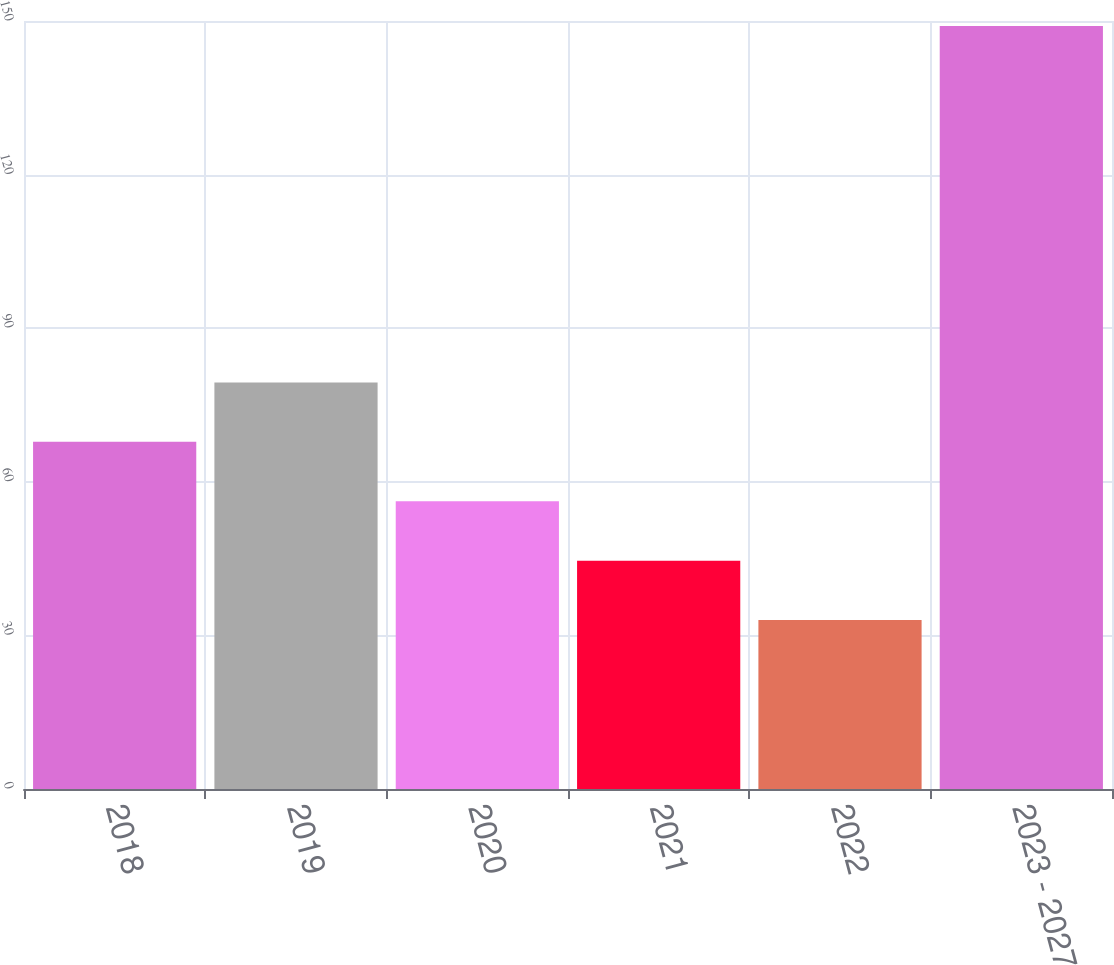<chart> <loc_0><loc_0><loc_500><loc_500><bar_chart><fcel>2018<fcel>2019<fcel>2020<fcel>2021<fcel>2022<fcel>2023 - 2027<nl><fcel>67.8<fcel>79.4<fcel>56.2<fcel>44.6<fcel>33<fcel>149<nl></chart> 